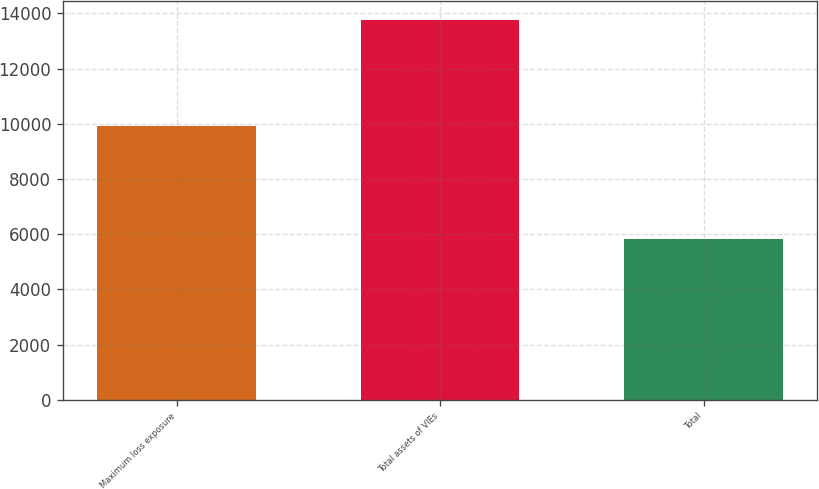<chart> <loc_0><loc_0><loc_500><loc_500><bar_chart><fcel>Maximum loss exposure<fcel>Total assets of VIEs<fcel>Total<nl><fcel>9904<fcel>13755<fcel>5826<nl></chart> 